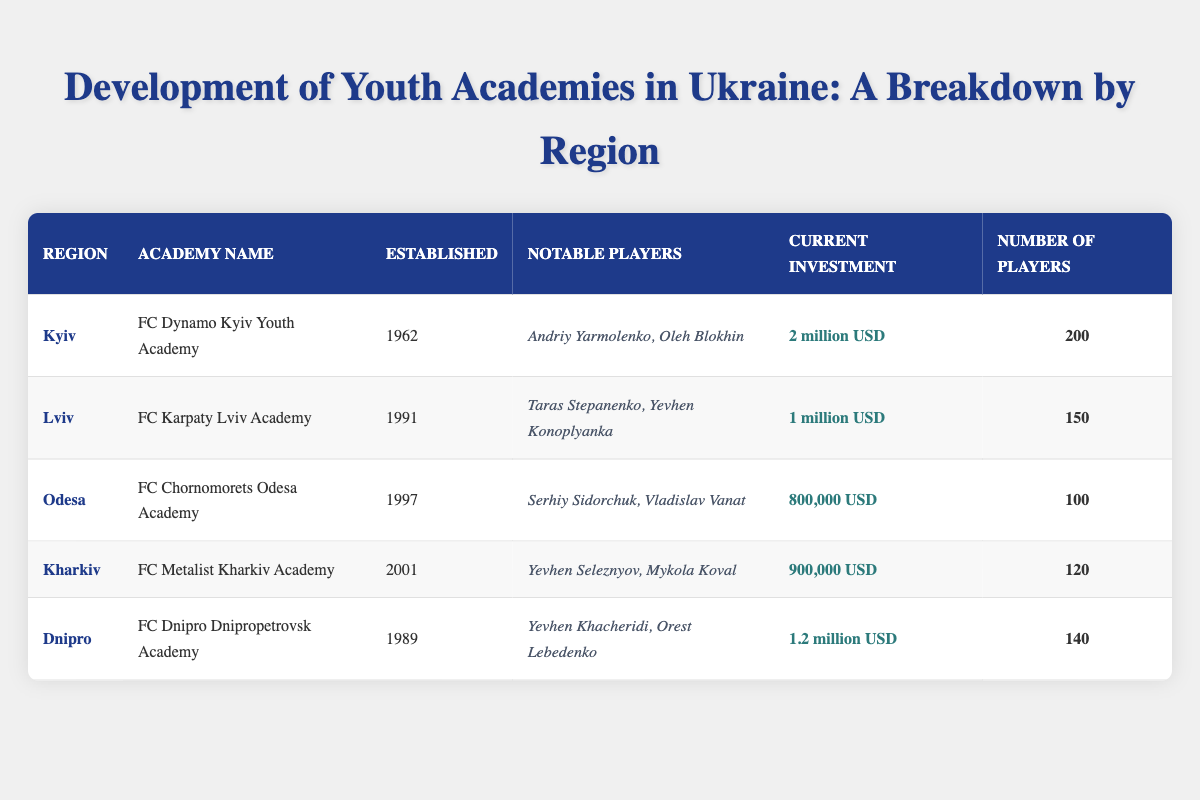What is the established year of the FC Dynamo Kyiv Youth Academy? The established year of the FC Dynamo Kyiv Youth Academy is directly listed in the table under the 'Established' column for the Kyiv region.
Answer: 1962 Which region has the highest number of players in its youth academy? The table shows the number of players for each academy. By comparing the numbers, Kyiv has 200 players, which is the highest among all regions listed.
Answer: Kyiv How much is the total current investment across all youth academies? The current investments listed are 2 million USD (Kyiv), 1 million USD (Lviv), 800,000 USD (Odesa), 900,000 USD (Kharkiv), and 1.2 million USD (Dnipro). Adding these amounts gives: 2 + 1 + 0.8 + 0.9 + 1.2 = 6 million USD.
Answer: 6 million USD Is there a youth academy in Odesa that has notable players who have played in the national team? Yes, the table indicates that FC Chornomorets Odesa Academy has notable players, Serhiy Sidorchuk and Vladislav Vanat, who have represented Ukraine at the national level.
Answer: Yes What is the average current investment per academy? The total current investment is 6 million USD (as calculated previously), and there are 5 academies. Dividing 6 million by 5 gives 6 million / 5 = 1.2 million USD average investment per academy.
Answer: 1.2 million USD Which region's academy was established most recently? By examining the 'Established' column, it can be seen that the last dated academy is FC Metalist Kharkiv Academy, established in 2001.
Answer: Kharkiv Does the FC Dnipro Dnipropetrovsk Academy have fewer players than the FC Karpaty Lviv Academy? The FC Dnipro Dnipropetrovsk Academy has 140 players, whereas the FC Karpaty Lviv Academy has 150 players. Thus, Dnipro has fewer players than Lviv.
Answer: Yes What is the difference in the number of players between the FC Dynamo Kyiv Youth Academy and the FC Chornomorets Odesa Academy? The FC Dynamo Kyiv Youth Academy has 200 players, while the FC Chornomorets Odesa Academy has 100 players. The difference is 200 - 100 = 100 players.
Answer: 100 players Which notable player from the FC Karpaty Lviv Academy established significant recognition in the international football scene? One notable player from the FC Karpaty Lviv Academy is Yevhen Konoplyanka, who has gained significant recognition internationally.
Answer: Yevhen Konoplyanka 